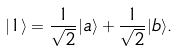<formula> <loc_0><loc_0><loc_500><loc_500>| 1 \rangle = \frac { 1 } { \sqrt { 2 } } | a \rangle + \frac { 1 } { \sqrt { 2 } } | b \rangle .</formula> 